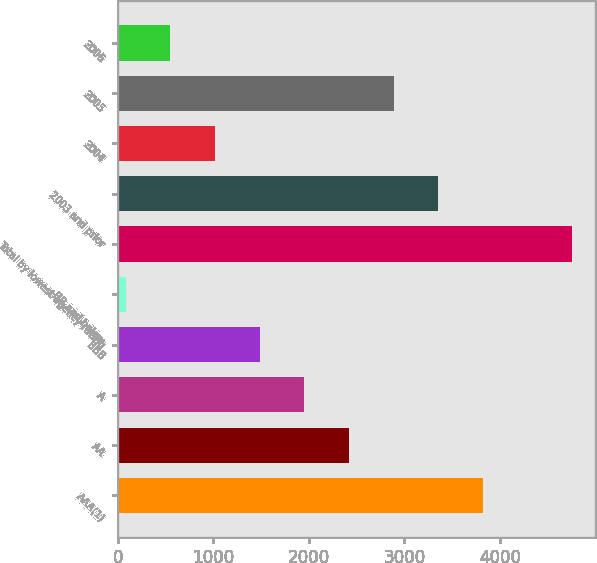<chart> <loc_0><loc_0><loc_500><loc_500><bar_chart><fcel>AAA(1)<fcel>AA<fcel>A<fcel>BBB<fcel>BB and below<fcel>Total by lowest agency rating<fcel>2003 and prior<fcel>2004<fcel>2005<fcel>2006<nl><fcel>3820.34<fcel>2419.25<fcel>1952.22<fcel>1485.19<fcel>84.1<fcel>4754.4<fcel>3353.31<fcel>1018.16<fcel>2886.28<fcel>551.13<nl></chart> 